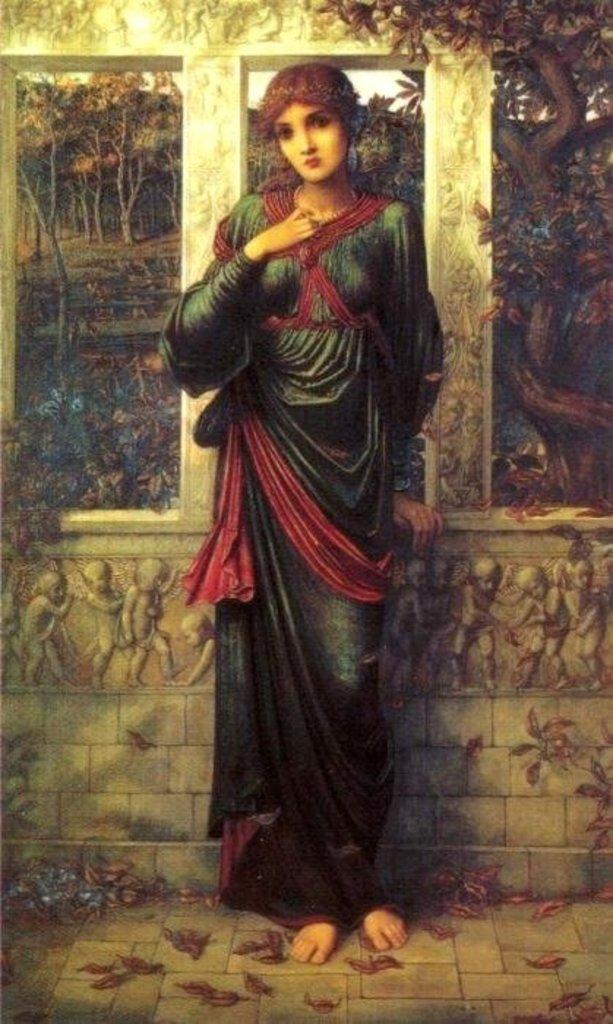What is depicted in the painting in the image? There is a painting of a woman standing in the image. What can be seen in the background of the painting? There is a wall and trees in the background of the painting. What is visible at the top of the image? The sky is visible at the top of the image. What might be found on the floor in the image? There are dried leaves on the floor in the image. What type of education does the tin minister in the image provide? There is no tin minister present in the image; it features a painting of a woman. 